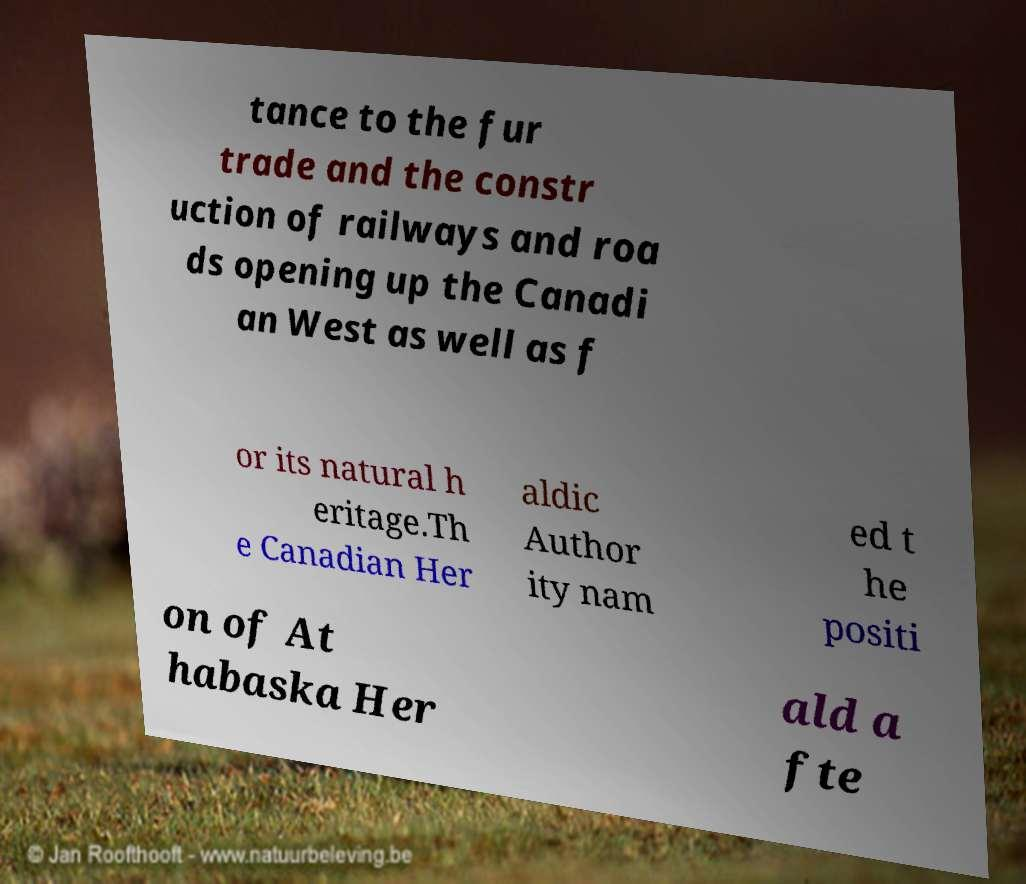What messages or text are displayed in this image? I need them in a readable, typed format. tance to the fur trade and the constr uction of railways and roa ds opening up the Canadi an West as well as f or its natural h eritage.Th e Canadian Her aldic Author ity nam ed t he positi on of At habaska Her ald a fte 